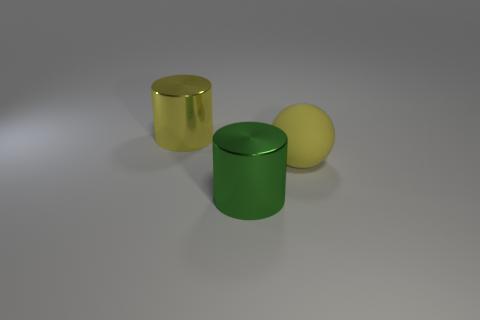Subtract all purple cylinders. Subtract all cyan blocks. How many cylinders are left? 2 Add 2 big green things. How many objects exist? 5 Subtract all balls. How many objects are left? 2 Subtract 0 cyan blocks. How many objects are left? 3 Subtract all large yellow rubber cylinders. Subtract all yellow objects. How many objects are left? 1 Add 1 shiny cylinders. How many shiny cylinders are left? 3 Add 1 big cylinders. How many big cylinders exist? 3 